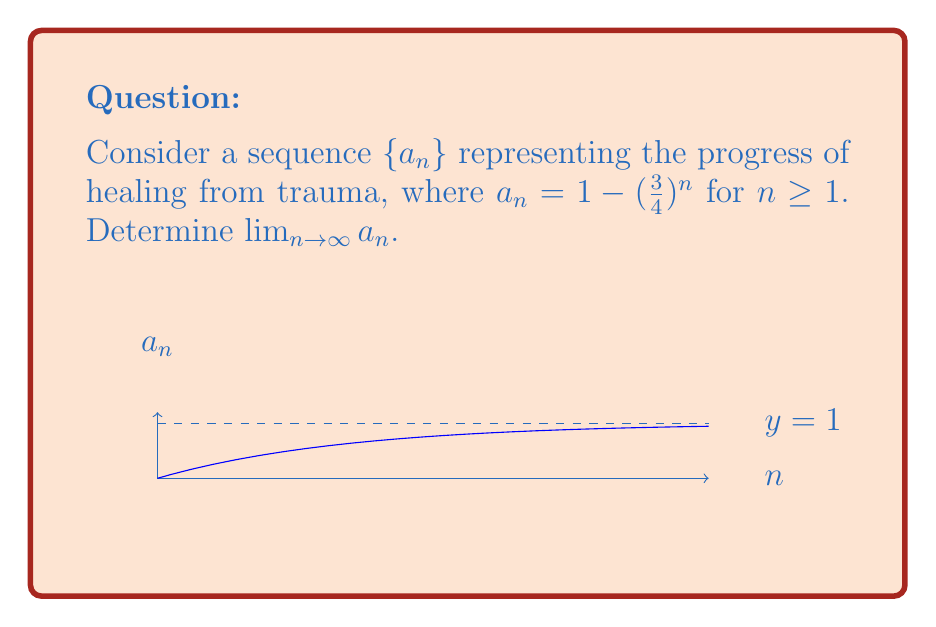Teach me how to tackle this problem. Let's approach this step-by-step:

1) First, we need to understand what the sequence represents:
   $a_n = 1 - (\frac{3}{4})^n$

2) As $n$ increases, $(\frac{3}{4})^n$ will get smaller because $\frac{3}{4} < 1$.

3) To find the limit, we can use the fact that for $|r| < 1$, $\lim_{n \to \infty} r^n = 0$.

4) In this case, $r = \frac{3}{4}$, which is indeed less than 1.

5) So, $\lim_{n \to \infty} (\frac{3}{4})^n = 0$

6) Now, let's look at the full sequence:
   
   $\lim_{n \to \infty} a_n = \lim_{n \to \infty} [1 - (\frac{3}{4})^n]$

7) We can split this limit:
   
   $= 1 - \lim_{n \to \infty} (\frac{3}{4})^n$

8) From step 5, we know the limit of $(\frac{3}{4})^n$ is 0.

9) Therefore:
   
   $= 1 - 0 = 1$

Thus, the sequence approaches 1 as $n$ approaches infinity.
Answer: $1$ 